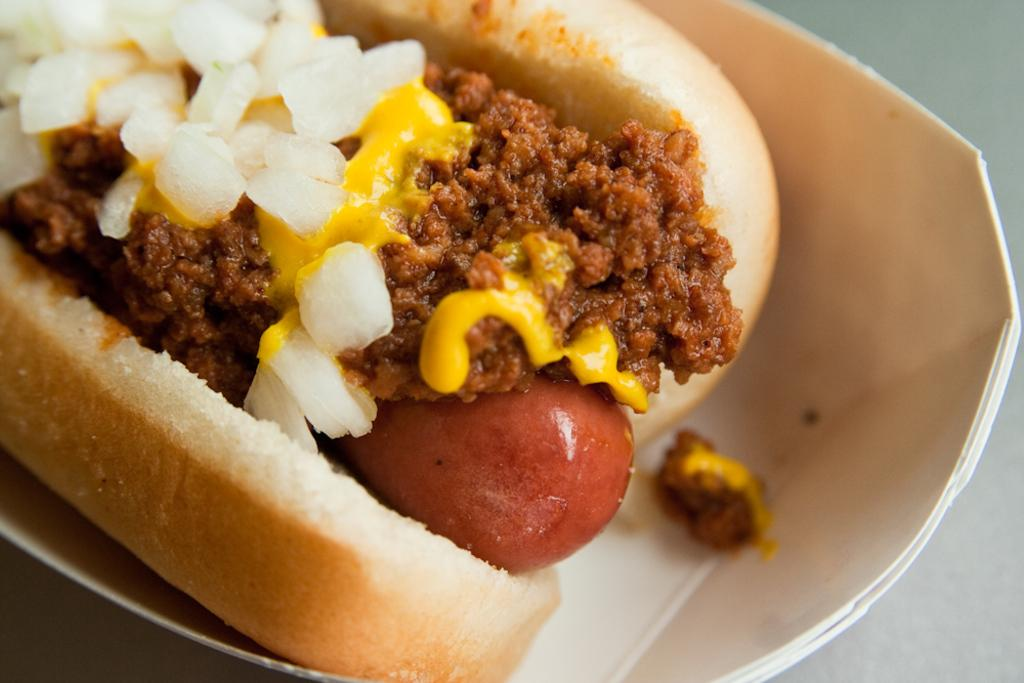What is in the bowl that is visible in the image? The bowl contains bread and food items. Where might the bowl be placed in the image? The bowl may be placed on a table. What type of setting is suggested by the image? The image is likely taken in a room. How many women are present in the image? There is no information about women in the image, as it only features a bowl with bread and food items. 